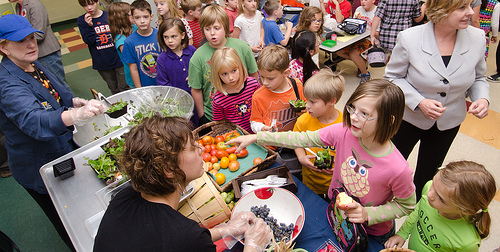<image>
Is there a cap on the person? No. The cap is not positioned on the person. They may be near each other, but the cap is not supported by or resting on top of the person. 